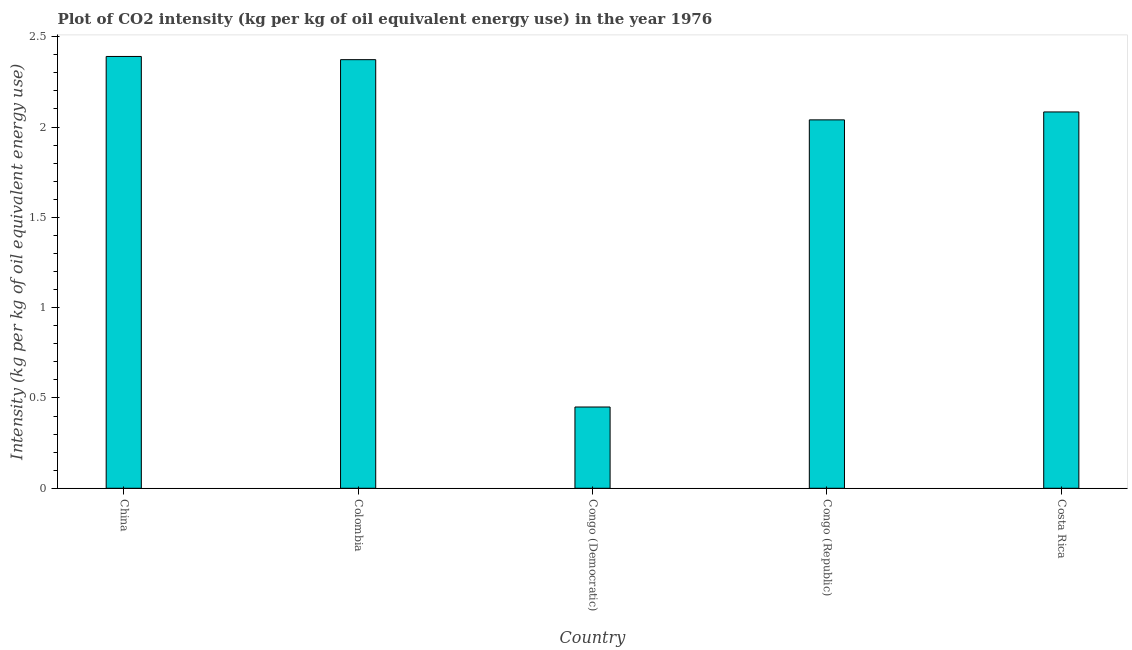Does the graph contain any zero values?
Your answer should be compact. No. Does the graph contain grids?
Provide a short and direct response. No. What is the title of the graph?
Your answer should be very brief. Plot of CO2 intensity (kg per kg of oil equivalent energy use) in the year 1976. What is the label or title of the Y-axis?
Ensure brevity in your answer.  Intensity (kg per kg of oil equivalent energy use). What is the co2 intensity in Colombia?
Make the answer very short. 2.37. Across all countries, what is the maximum co2 intensity?
Provide a succinct answer. 2.39. Across all countries, what is the minimum co2 intensity?
Your answer should be very brief. 0.45. In which country was the co2 intensity maximum?
Make the answer very short. China. In which country was the co2 intensity minimum?
Keep it short and to the point. Congo (Democratic). What is the sum of the co2 intensity?
Offer a very short reply. 9.34. What is the difference between the co2 intensity in Congo (Republic) and Costa Rica?
Give a very brief answer. -0.04. What is the average co2 intensity per country?
Provide a short and direct response. 1.87. What is the median co2 intensity?
Your answer should be compact. 2.08. Is the co2 intensity in Congo (Democratic) less than that in Congo (Republic)?
Offer a very short reply. Yes. What is the difference between the highest and the second highest co2 intensity?
Your answer should be compact. 0.02. Is the sum of the co2 intensity in Colombia and Costa Rica greater than the maximum co2 intensity across all countries?
Keep it short and to the point. Yes. What is the difference between the highest and the lowest co2 intensity?
Keep it short and to the point. 1.94. How many bars are there?
Make the answer very short. 5. How many countries are there in the graph?
Provide a succinct answer. 5. Are the values on the major ticks of Y-axis written in scientific E-notation?
Make the answer very short. No. What is the Intensity (kg per kg of oil equivalent energy use) in China?
Provide a succinct answer. 2.39. What is the Intensity (kg per kg of oil equivalent energy use) in Colombia?
Provide a short and direct response. 2.37. What is the Intensity (kg per kg of oil equivalent energy use) of Congo (Democratic)?
Give a very brief answer. 0.45. What is the Intensity (kg per kg of oil equivalent energy use) in Congo (Republic)?
Provide a short and direct response. 2.04. What is the Intensity (kg per kg of oil equivalent energy use) of Costa Rica?
Your answer should be compact. 2.08. What is the difference between the Intensity (kg per kg of oil equivalent energy use) in China and Colombia?
Offer a terse response. 0.02. What is the difference between the Intensity (kg per kg of oil equivalent energy use) in China and Congo (Democratic)?
Give a very brief answer. 1.94. What is the difference between the Intensity (kg per kg of oil equivalent energy use) in China and Congo (Republic)?
Provide a succinct answer. 0.35. What is the difference between the Intensity (kg per kg of oil equivalent energy use) in China and Costa Rica?
Your response must be concise. 0.31. What is the difference between the Intensity (kg per kg of oil equivalent energy use) in Colombia and Congo (Democratic)?
Provide a succinct answer. 1.92. What is the difference between the Intensity (kg per kg of oil equivalent energy use) in Colombia and Costa Rica?
Your response must be concise. 0.29. What is the difference between the Intensity (kg per kg of oil equivalent energy use) in Congo (Democratic) and Congo (Republic)?
Keep it short and to the point. -1.59. What is the difference between the Intensity (kg per kg of oil equivalent energy use) in Congo (Democratic) and Costa Rica?
Your answer should be very brief. -1.63. What is the difference between the Intensity (kg per kg of oil equivalent energy use) in Congo (Republic) and Costa Rica?
Ensure brevity in your answer.  -0.04. What is the ratio of the Intensity (kg per kg of oil equivalent energy use) in China to that in Colombia?
Provide a short and direct response. 1.01. What is the ratio of the Intensity (kg per kg of oil equivalent energy use) in China to that in Congo (Democratic)?
Offer a terse response. 5.31. What is the ratio of the Intensity (kg per kg of oil equivalent energy use) in China to that in Congo (Republic)?
Provide a short and direct response. 1.17. What is the ratio of the Intensity (kg per kg of oil equivalent energy use) in China to that in Costa Rica?
Provide a short and direct response. 1.15. What is the ratio of the Intensity (kg per kg of oil equivalent energy use) in Colombia to that in Congo (Democratic)?
Offer a terse response. 5.27. What is the ratio of the Intensity (kg per kg of oil equivalent energy use) in Colombia to that in Congo (Republic)?
Make the answer very short. 1.16. What is the ratio of the Intensity (kg per kg of oil equivalent energy use) in Colombia to that in Costa Rica?
Your answer should be very brief. 1.14. What is the ratio of the Intensity (kg per kg of oil equivalent energy use) in Congo (Democratic) to that in Congo (Republic)?
Your answer should be compact. 0.22. What is the ratio of the Intensity (kg per kg of oil equivalent energy use) in Congo (Democratic) to that in Costa Rica?
Provide a succinct answer. 0.22. 